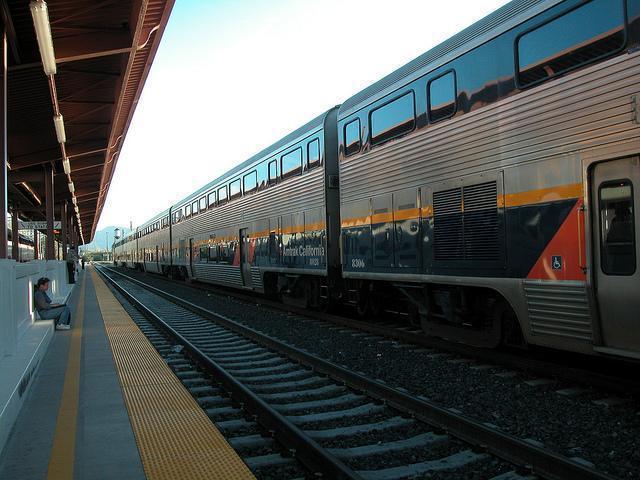What color is the triangle halves on the side of the bus next to the luggage holders?
Answer the question by selecting the correct answer among the 4 following choices.
Options: Black, green, yellow, orange. Orange. 